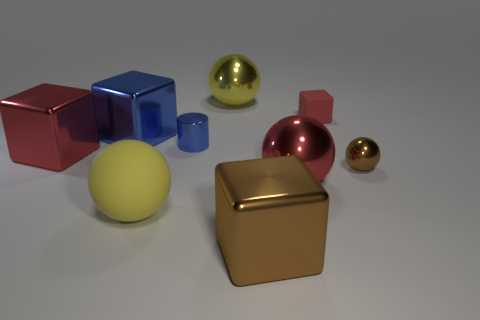Can you describe the shapes and colors of the objects seen in the picture? Certainly! The image showcases a collection of geometric shapes including a large red cube, a small blue cube, a large yellow sphere, a small pink sphere, a large gold-toned matte cube, and a small shiny gold sphere. The objects vary not only in color and size but also in surface texture, with some exhibiting a matte finish and others a glossy sheen. 